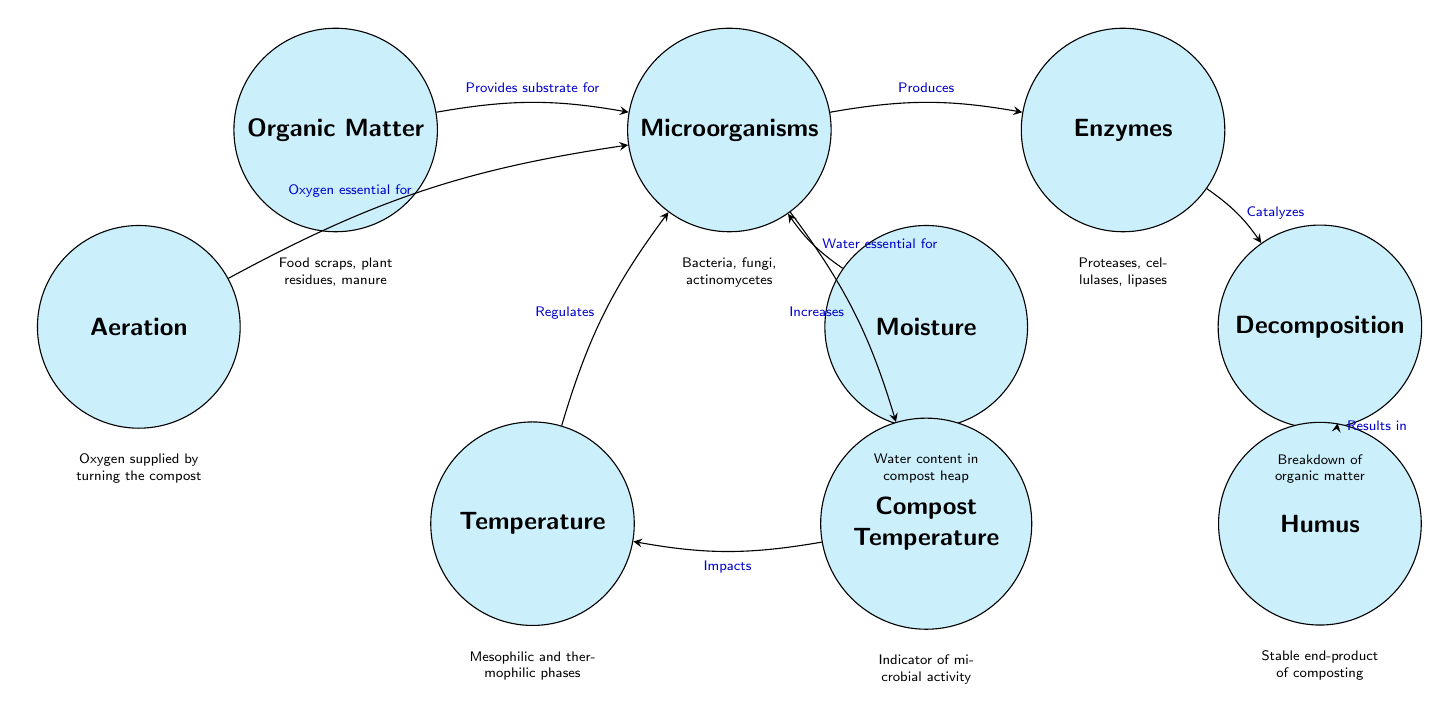What is the starting material in organic composting? The diagram starts with the node labeled "Organic Matter," which refers to the initial input for the composting process. This includes food scraps, plant residues, and manure as specified in the details below the node.
Answer: Organic Matter Who produces enzymes during the composting process? The diagram indicates that "Microorganisms" produce "Enzymes." This relationship is shown with an arrow pointing from the microorganisms node to the enzymes node, highlighting the production of enzymes as a result of microbial activity.
Answer: Microorganisms What does the decomposition process result in? According to the diagram, the node labeled "Decomposition" leads to the node "Humus," which is noted as the stable end-product of composting. This is shown by the connecting arrow indicating the outcome of decomposition.
Answer: Humus How does temperature affect microbial activity? The diagram presents "Temperature" as a regulatory factor affecting "Microorganisms." The arrow from "Temperature" to "Microorganisms" conveys that it regulates their activity levels, highlighting temperature's importance in composting.
Answer: Regulates How is oxygen supplied to microorganisms? In the diagram, "Aeration" provides "Oxygen essential for" "Microorganisms." The description notes that oxygen is supplied through the action of turning the compost, which is indicated by the connection from the aeration node.
Answer: Turning the compost What impacts compost temperature? The arrow in the diagram points from "Compost Temperature" to "Temperature," indicating that the compost temperature influences the temperature within the compost heap. This suggests a feedback loop where temperature levels regulate and affect microbial processes.
Answer: Impacts What is an indicator of microbial activity? The diagram connects "Microorganisms" to "Compost Temperature," describing the compost temperature as an indicator of microbial activity. The relationship shows that observing compost temperature helps to assess the level of microbial processes at play.
Answer: Compost Temperature What type of microorganisms are involved in composting? The node labeled "Microorganisms" contains a description that specifies the types involved: bacteria, fungi, and actinomycetes. This clearly identifies the various organisms working in the composting process.
Answer: Bacteria, fungi, actinomycetes How does moisture affect microorganisms? The diagram shows that "Moisture" is essential for "Microorganisms." The connection implies that maintaining appropriate moisture levels is critical for their activity, which directly influences the composting process.
Answer: Water essential for 